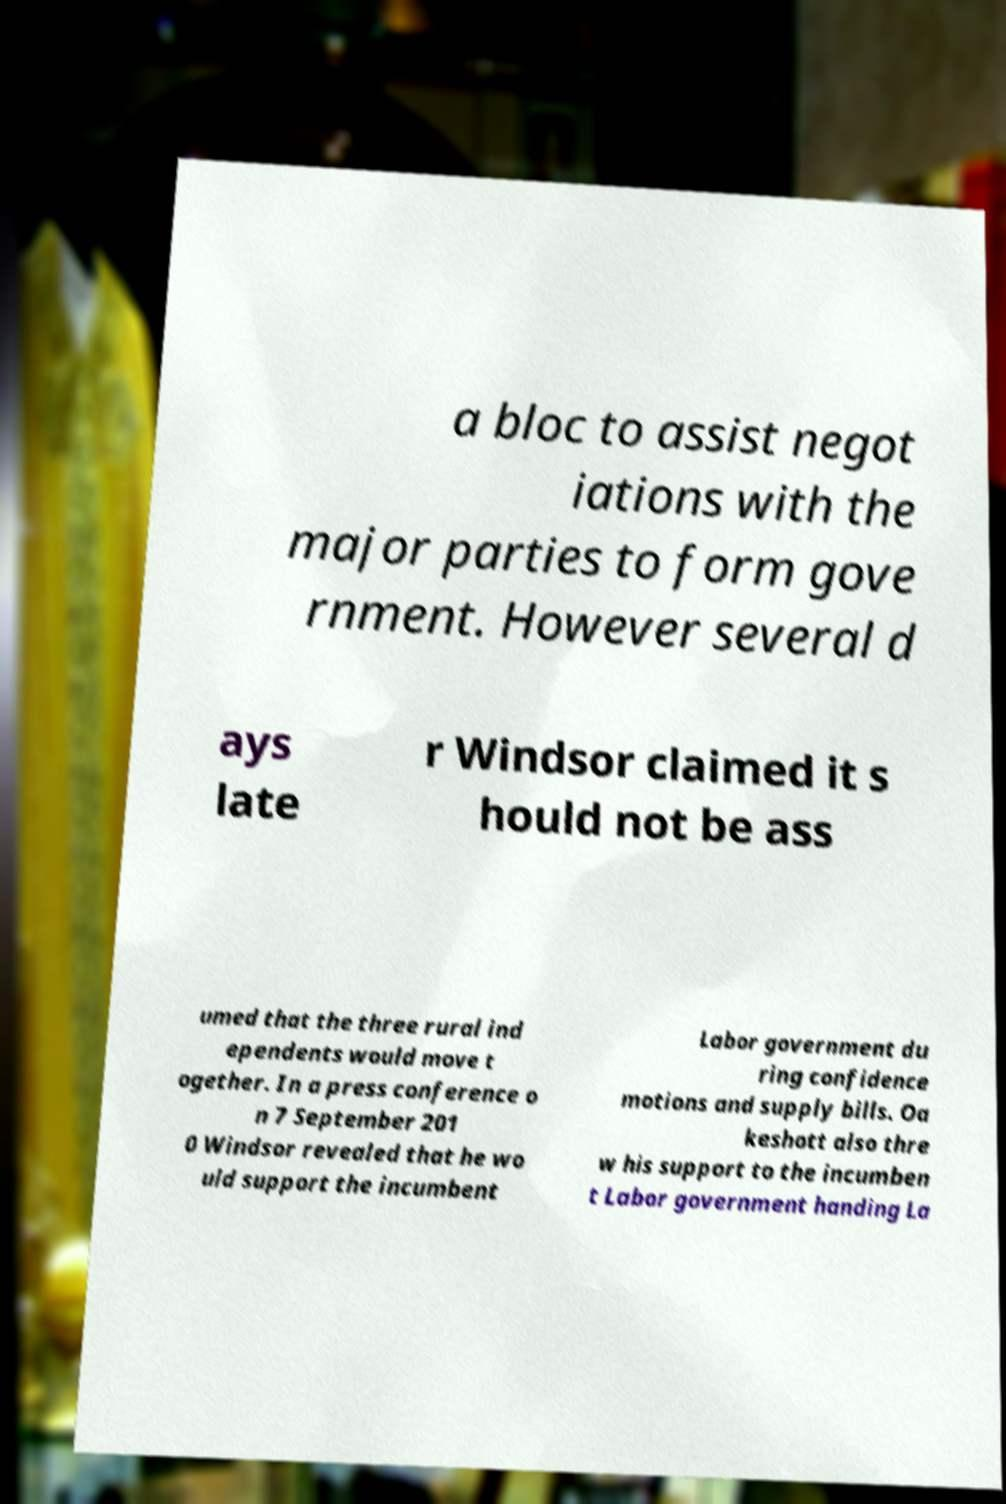For documentation purposes, I need the text within this image transcribed. Could you provide that? a bloc to assist negot iations with the major parties to form gove rnment. However several d ays late r Windsor claimed it s hould not be ass umed that the three rural ind ependents would move t ogether. In a press conference o n 7 September 201 0 Windsor revealed that he wo uld support the incumbent Labor government du ring confidence motions and supply bills. Oa keshott also thre w his support to the incumben t Labor government handing La 